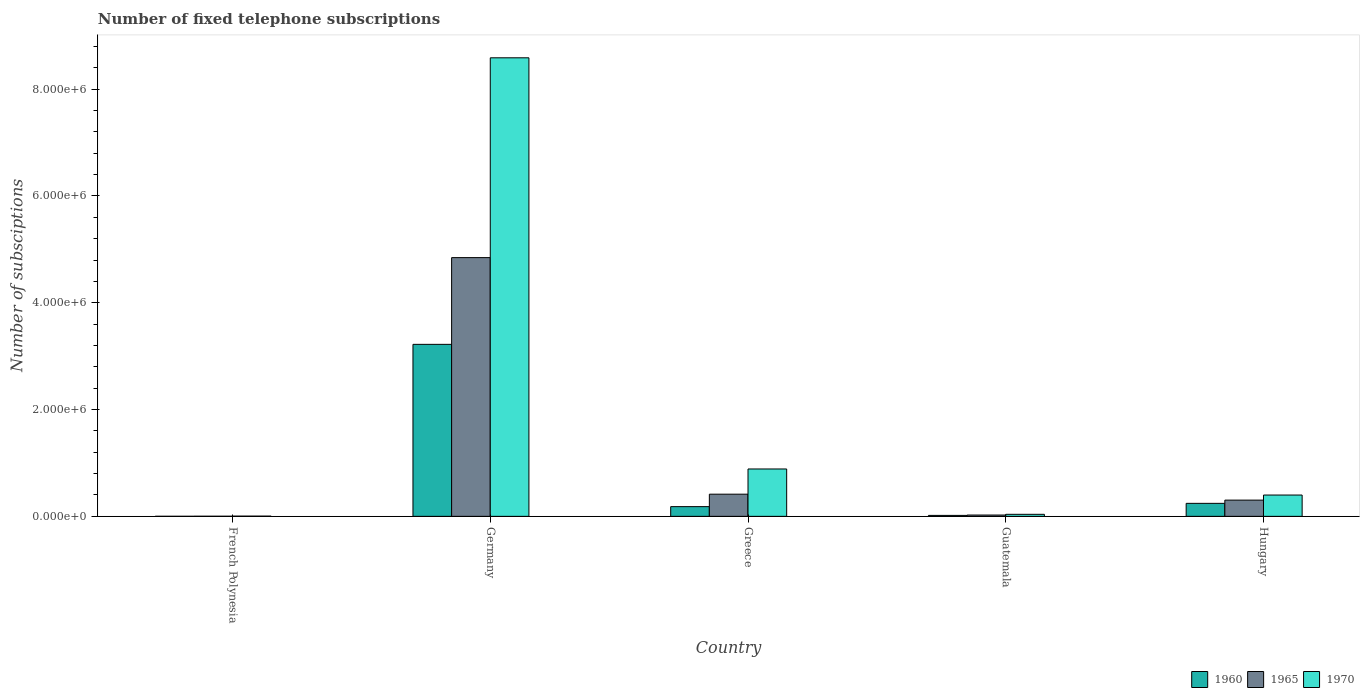How many different coloured bars are there?
Give a very brief answer. 3. How many groups of bars are there?
Offer a very short reply. 5. Are the number of bars per tick equal to the number of legend labels?
Ensure brevity in your answer.  Yes. Are the number of bars on each tick of the X-axis equal?
Your response must be concise. Yes. What is the label of the 5th group of bars from the left?
Your response must be concise. Hungary. What is the number of fixed telephone subscriptions in 1970 in French Polynesia?
Offer a terse response. 4000. Across all countries, what is the maximum number of fixed telephone subscriptions in 1960?
Provide a short and direct response. 3.22e+06. Across all countries, what is the minimum number of fixed telephone subscriptions in 1965?
Ensure brevity in your answer.  1900. In which country was the number of fixed telephone subscriptions in 1970 minimum?
Your answer should be compact. French Polynesia. What is the total number of fixed telephone subscriptions in 1965 in the graph?
Offer a very short reply. 5.59e+06. What is the difference between the number of fixed telephone subscriptions in 1970 in French Polynesia and that in Germany?
Give a very brief answer. -8.58e+06. What is the difference between the number of fixed telephone subscriptions in 1960 in Germany and the number of fixed telephone subscriptions in 1965 in Greece?
Your answer should be compact. 2.81e+06. What is the average number of fixed telephone subscriptions in 1965 per country?
Ensure brevity in your answer.  1.12e+06. What is the difference between the number of fixed telephone subscriptions of/in 1960 and number of fixed telephone subscriptions of/in 1965 in Guatemala?
Your answer should be compact. -6485. In how many countries, is the number of fixed telephone subscriptions in 1960 greater than 5200000?
Give a very brief answer. 0. What is the ratio of the number of fixed telephone subscriptions in 1960 in Germany to that in Guatemala?
Offer a very short reply. 180.74. What is the difference between the highest and the second highest number of fixed telephone subscriptions in 1960?
Keep it short and to the point. -2.98e+06. What is the difference between the highest and the lowest number of fixed telephone subscriptions in 1970?
Keep it short and to the point. 8.58e+06. What does the 2nd bar from the left in Germany represents?
Your answer should be compact. 1965. What does the 2nd bar from the right in Greece represents?
Keep it short and to the point. 1965. Is it the case that in every country, the sum of the number of fixed telephone subscriptions in 1965 and number of fixed telephone subscriptions in 1970 is greater than the number of fixed telephone subscriptions in 1960?
Offer a very short reply. Yes. Does the graph contain any zero values?
Your response must be concise. No. What is the title of the graph?
Your response must be concise. Number of fixed telephone subscriptions. What is the label or title of the X-axis?
Your answer should be very brief. Country. What is the label or title of the Y-axis?
Your answer should be very brief. Number of subsciptions. What is the Number of subsciptions in 1960 in French Polynesia?
Give a very brief answer. 827. What is the Number of subsciptions in 1965 in French Polynesia?
Give a very brief answer. 1900. What is the Number of subsciptions of 1970 in French Polynesia?
Keep it short and to the point. 4000. What is the Number of subsciptions of 1960 in Germany?
Give a very brief answer. 3.22e+06. What is the Number of subsciptions of 1965 in Germany?
Keep it short and to the point. 4.84e+06. What is the Number of subsciptions of 1970 in Germany?
Your answer should be compact. 8.59e+06. What is the Number of subsciptions of 1960 in Greece?
Your answer should be compact. 1.82e+05. What is the Number of subsciptions in 1965 in Greece?
Keep it short and to the point. 4.15e+05. What is the Number of subsciptions of 1970 in Greece?
Provide a short and direct response. 8.87e+05. What is the Number of subsciptions of 1960 in Guatemala?
Offer a terse response. 1.78e+04. What is the Number of subsciptions of 1965 in Guatemala?
Provide a succinct answer. 2.43e+04. What is the Number of subsciptions of 1970 in Guatemala?
Provide a short and direct response. 3.79e+04. What is the Number of subsciptions in 1960 in Hungary?
Give a very brief answer. 2.43e+05. What is the Number of subsciptions in 1965 in Hungary?
Make the answer very short. 3.04e+05. What is the Number of subsciptions of 1970 in Hungary?
Give a very brief answer. 3.99e+05. Across all countries, what is the maximum Number of subsciptions in 1960?
Keep it short and to the point. 3.22e+06. Across all countries, what is the maximum Number of subsciptions of 1965?
Your response must be concise. 4.84e+06. Across all countries, what is the maximum Number of subsciptions in 1970?
Provide a short and direct response. 8.59e+06. Across all countries, what is the minimum Number of subsciptions of 1960?
Provide a succinct answer. 827. Across all countries, what is the minimum Number of subsciptions of 1965?
Ensure brevity in your answer.  1900. Across all countries, what is the minimum Number of subsciptions of 1970?
Your answer should be very brief. 4000. What is the total Number of subsciptions in 1960 in the graph?
Keep it short and to the point. 3.66e+06. What is the total Number of subsciptions of 1965 in the graph?
Ensure brevity in your answer.  5.59e+06. What is the total Number of subsciptions of 1970 in the graph?
Ensure brevity in your answer.  9.91e+06. What is the difference between the Number of subsciptions of 1960 in French Polynesia and that in Germany?
Your answer should be compact. -3.22e+06. What is the difference between the Number of subsciptions of 1965 in French Polynesia and that in Germany?
Keep it short and to the point. -4.84e+06. What is the difference between the Number of subsciptions in 1970 in French Polynesia and that in Germany?
Offer a terse response. -8.58e+06. What is the difference between the Number of subsciptions in 1960 in French Polynesia and that in Greece?
Your answer should be compact. -1.81e+05. What is the difference between the Number of subsciptions in 1965 in French Polynesia and that in Greece?
Make the answer very short. -4.13e+05. What is the difference between the Number of subsciptions in 1970 in French Polynesia and that in Greece?
Give a very brief answer. -8.83e+05. What is the difference between the Number of subsciptions in 1960 in French Polynesia and that in Guatemala?
Offer a very short reply. -1.70e+04. What is the difference between the Number of subsciptions of 1965 in French Polynesia and that in Guatemala?
Offer a terse response. -2.24e+04. What is the difference between the Number of subsciptions of 1970 in French Polynesia and that in Guatemala?
Keep it short and to the point. -3.39e+04. What is the difference between the Number of subsciptions in 1960 in French Polynesia and that in Hungary?
Keep it short and to the point. -2.43e+05. What is the difference between the Number of subsciptions of 1965 in French Polynesia and that in Hungary?
Offer a very short reply. -3.02e+05. What is the difference between the Number of subsciptions of 1970 in French Polynesia and that in Hungary?
Your answer should be compact. -3.95e+05. What is the difference between the Number of subsciptions in 1960 in Germany and that in Greece?
Offer a terse response. 3.04e+06. What is the difference between the Number of subsciptions in 1965 in Germany and that in Greece?
Your response must be concise. 4.43e+06. What is the difference between the Number of subsciptions in 1970 in Germany and that in Greece?
Ensure brevity in your answer.  7.70e+06. What is the difference between the Number of subsciptions of 1960 in Germany and that in Guatemala?
Keep it short and to the point. 3.20e+06. What is the difference between the Number of subsciptions of 1965 in Germany and that in Guatemala?
Give a very brief answer. 4.82e+06. What is the difference between the Number of subsciptions of 1970 in Germany and that in Guatemala?
Your answer should be compact. 8.55e+06. What is the difference between the Number of subsciptions in 1960 in Germany and that in Hungary?
Keep it short and to the point. 2.98e+06. What is the difference between the Number of subsciptions of 1965 in Germany and that in Hungary?
Provide a succinct answer. 4.54e+06. What is the difference between the Number of subsciptions in 1970 in Germany and that in Hungary?
Offer a very short reply. 8.19e+06. What is the difference between the Number of subsciptions of 1960 in Greece and that in Guatemala?
Provide a short and direct response. 1.64e+05. What is the difference between the Number of subsciptions in 1965 in Greece and that in Guatemala?
Your response must be concise. 3.91e+05. What is the difference between the Number of subsciptions of 1970 in Greece and that in Guatemala?
Give a very brief answer. 8.49e+05. What is the difference between the Number of subsciptions in 1960 in Greece and that in Hungary?
Offer a very short reply. -6.17e+04. What is the difference between the Number of subsciptions of 1965 in Greece and that in Hungary?
Ensure brevity in your answer.  1.11e+05. What is the difference between the Number of subsciptions in 1970 in Greece and that in Hungary?
Make the answer very short. 4.88e+05. What is the difference between the Number of subsciptions of 1960 in Guatemala and that in Hungary?
Keep it short and to the point. -2.26e+05. What is the difference between the Number of subsciptions in 1965 in Guatemala and that in Hungary?
Offer a very short reply. -2.79e+05. What is the difference between the Number of subsciptions in 1970 in Guatemala and that in Hungary?
Offer a terse response. -3.61e+05. What is the difference between the Number of subsciptions in 1960 in French Polynesia and the Number of subsciptions in 1965 in Germany?
Your answer should be very brief. -4.84e+06. What is the difference between the Number of subsciptions of 1960 in French Polynesia and the Number of subsciptions of 1970 in Germany?
Offer a very short reply. -8.59e+06. What is the difference between the Number of subsciptions in 1965 in French Polynesia and the Number of subsciptions in 1970 in Germany?
Provide a short and direct response. -8.59e+06. What is the difference between the Number of subsciptions in 1960 in French Polynesia and the Number of subsciptions in 1965 in Greece?
Make the answer very short. -4.14e+05. What is the difference between the Number of subsciptions in 1960 in French Polynesia and the Number of subsciptions in 1970 in Greece?
Give a very brief answer. -8.86e+05. What is the difference between the Number of subsciptions in 1965 in French Polynesia and the Number of subsciptions in 1970 in Greece?
Provide a short and direct response. -8.85e+05. What is the difference between the Number of subsciptions of 1960 in French Polynesia and the Number of subsciptions of 1965 in Guatemala?
Provide a succinct answer. -2.35e+04. What is the difference between the Number of subsciptions in 1960 in French Polynesia and the Number of subsciptions in 1970 in Guatemala?
Make the answer very short. -3.70e+04. What is the difference between the Number of subsciptions in 1965 in French Polynesia and the Number of subsciptions in 1970 in Guatemala?
Keep it short and to the point. -3.60e+04. What is the difference between the Number of subsciptions in 1960 in French Polynesia and the Number of subsciptions in 1965 in Hungary?
Give a very brief answer. -3.03e+05. What is the difference between the Number of subsciptions of 1960 in French Polynesia and the Number of subsciptions of 1970 in Hungary?
Keep it short and to the point. -3.98e+05. What is the difference between the Number of subsciptions in 1965 in French Polynesia and the Number of subsciptions in 1970 in Hungary?
Provide a short and direct response. -3.97e+05. What is the difference between the Number of subsciptions in 1960 in Germany and the Number of subsciptions in 1965 in Greece?
Your answer should be very brief. 2.81e+06. What is the difference between the Number of subsciptions in 1960 in Germany and the Number of subsciptions in 1970 in Greece?
Your answer should be very brief. 2.33e+06. What is the difference between the Number of subsciptions in 1965 in Germany and the Number of subsciptions in 1970 in Greece?
Ensure brevity in your answer.  3.96e+06. What is the difference between the Number of subsciptions in 1960 in Germany and the Number of subsciptions in 1965 in Guatemala?
Provide a succinct answer. 3.20e+06. What is the difference between the Number of subsciptions in 1960 in Germany and the Number of subsciptions in 1970 in Guatemala?
Offer a very short reply. 3.18e+06. What is the difference between the Number of subsciptions of 1965 in Germany and the Number of subsciptions of 1970 in Guatemala?
Ensure brevity in your answer.  4.81e+06. What is the difference between the Number of subsciptions of 1960 in Germany and the Number of subsciptions of 1965 in Hungary?
Provide a succinct answer. 2.92e+06. What is the difference between the Number of subsciptions in 1960 in Germany and the Number of subsciptions in 1970 in Hungary?
Ensure brevity in your answer.  2.82e+06. What is the difference between the Number of subsciptions in 1965 in Germany and the Number of subsciptions in 1970 in Hungary?
Your answer should be compact. 4.45e+06. What is the difference between the Number of subsciptions in 1960 in Greece and the Number of subsciptions in 1965 in Guatemala?
Give a very brief answer. 1.57e+05. What is the difference between the Number of subsciptions of 1960 in Greece and the Number of subsciptions of 1970 in Guatemala?
Provide a short and direct response. 1.44e+05. What is the difference between the Number of subsciptions of 1965 in Greece and the Number of subsciptions of 1970 in Guatemala?
Ensure brevity in your answer.  3.77e+05. What is the difference between the Number of subsciptions in 1960 in Greece and the Number of subsciptions in 1965 in Hungary?
Your response must be concise. -1.22e+05. What is the difference between the Number of subsciptions in 1960 in Greece and the Number of subsciptions in 1970 in Hungary?
Keep it short and to the point. -2.17e+05. What is the difference between the Number of subsciptions of 1965 in Greece and the Number of subsciptions of 1970 in Hungary?
Provide a succinct answer. 1.59e+04. What is the difference between the Number of subsciptions of 1960 in Guatemala and the Number of subsciptions of 1965 in Hungary?
Provide a short and direct response. -2.86e+05. What is the difference between the Number of subsciptions in 1960 in Guatemala and the Number of subsciptions in 1970 in Hungary?
Offer a very short reply. -3.81e+05. What is the difference between the Number of subsciptions in 1965 in Guatemala and the Number of subsciptions in 1970 in Hungary?
Keep it short and to the point. -3.75e+05. What is the average Number of subsciptions in 1960 per country?
Your answer should be very brief. 7.33e+05. What is the average Number of subsciptions in 1965 per country?
Provide a succinct answer. 1.12e+06. What is the average Number of subsciptions of 1970 per country?
Provide a succinct answer. 1.98e+06. What is the difference between the Number of subsciptions in 1960 and Number of subsciptions in 1965 in French Polynesia?
Offer a very short reply. -1073. What is the difference between the Number of subsciptions of 1960 and Number of subsciptions of 1970 in French Polynesia?
Make the answer very short. -3173. What is the difference between the Number of subsciptions in 1965 and Number of subsciptions in 1970 in French Polynesia?
Keep it short and to the point. -2100. What is the difference between the Number of subsciptions in 1960 and Number of subsciptions in 1965 in Germany?
Offer a terse response. -1.62e+06. What is the difference between the Number of subsciptions in 1960 and Number of subsciptions in 1970 in Germany?
Offer a terse response. -5.37e+06. What is the difference between the Number of subsciptions in 1965 and Number of subsciptions in 1970 in Germany?
Your answer should be very brief. -3.74e+06. What is the difference between the Number of subsciptions of 1960 and Number of subsciptions of 1965 in Greece?
Offer a very short reply. -2.33e+05. What is the difference between the Number of subsciptions of 1960 and Number of subsciptions of 1970 in Greece?
Your answer should be compact. -7.05e+05. What is the difference between the Number of subsciptions of 1965 and Number of subsciptions of 1970 in Greece?
Your answer should be compact. -4.72e+05. What is the difference between the Number of subsciptions of 1960 and Number of subsciptions of 1965 in Guatemala?
Your answer should be very brief. -6485. What is the difference between the Number of subsciptions of 1960 and Number of subsciptions of 1970 in Guatemala?
Keep it short and to the point. -2.00e+04. What is the difference between the Number of subsciptions in 1965 and Number of subsciptions in 1970 in Guatemala?
Offer a terse response. -1.36e+04. What is the difference between the Number of subsciptions of 1960 and Number of subsciptions of 1965 in Hungary?
Your answer should be very brief. -6.04e+04. What is the difference between the Number of subsciptions of 1960 and Number of subsciptions of 1970 in Hungary?
Provide a succinct answer. -1.56e+05. What is the difference between the Number of subsciptions of 1965 and Number of subsciptions of 1970 in Hungary?
Offer a terse response. -9.53e+04. What is the ratio of the Number of subsciptions in 1960 in French Polynesia to that in Germany?
Offer a very short reply. 0. What is the ratio of the Number of subsciptions of 1970 in French Polynesia to that in Germany?
Your answer should be very brief. 0. What is the ratio of the Number of subsciptions of 1960 in French Polynesia to that in Greece?
Your response must be concise. 0. What is the ratio of the Number of subsciptions in 1965 in French Polynesia to that in Greece?
Ensure brevity in your answer.  0. What is the ratio of the Number of subsciptions in 1970 in French Polynesia to that in Greece?
Your response must be concise. 0. What is the ratio of the Number of subsciptions in 1960 in French Polynesia to that in Guatemala?
Your answer should be very brief. 0.05. What is the ratio of the Number of subsciptions of 1965 in French Polynesia to that in Guatemala?
Keep it short and to the point. 0.08. What is the ratio of the Number of subsciptions of 1970 in French Polynesia to that in Guatemala?
Make the answer very short. 0.11. What is the ratio of the Number of subsciptions in 1960 in French Polynesia to that in Hungary?
Offer a very short reply. 0. What is the ratio of the Number of subsciptions in 1965 in French Polynesia to that in Hungary?
Your answer should be very brief. 0.01. What is the ratio of the Number of subsciptions of 1970 in French Polynesia to that in Hungary?
Make the answer very short. 0.01. What is the ratio of the Number of subsciptions in 1960 in Germany to that in Greece?
Give a very brief answer. 17.72. What is the ratio of the Number of subsciptions in 1965 in Germany to that in Greece?
Your response must be concise. 11.67. What is the ratio of the Number of subsciptions of 1970 in Germany to that in Greece?
Your response must be concise. 9.68. What is the ratio of the Number of subsciptions of 1960 in Germany to that in Guatemala?
Offer a terse response. 180.74. What is the ratio of the Number of subsciptions in 1965 in Germany to that in Guatemala?
Keep it short and to the point. 199.33. What is the ratio of the Number of subsciptions in 1970 in Germany to that in Guatemala?
Keep it short and to the point. 226.74. What is the ratio of the Number of subsciptions of 1960 in Germany to that in Hungary?
Your answer should be very brief. 13.23. What is the ratio of the Number of subsciptions of 1965 in Germany to that in Hungary?
Ensure brevity in your answer.  15.95. What is the ratio of the Number of subsciptions of 1970 in Germany to that in Hungary?
Your answer should be compact. 21.52. What is the ratio of the Number of subsciptions in 1960 in Greece to that in Guatemala?
Offer a very short reply. 10.2. What is the ratio of the Number of subsciptions in 1965 in Greece to that in Guatemala?
Provide a short and direct response. 17.07. What is the ratio of the Number of subsciptions of 1970 in Greece to that in Guatemala?
Make the answer very short. 23.42. What is the ratio of the Number of subsciptions in 1960 in Greece to that in Hungary?
Make the answer very short. 0.75. What is the ratio of the Number of subsciptions of 1965 in Greece to that in Hungary?
Offer a very short reply. 1.37. What is the ratio of the Number of subsciptions of 1970 in Greece to that in Hungary?
Offer a terse response. 2.22. What is the ratio of the Number of subsciptions of 1960 in Guatemala to that in Hungary?
Ensure brevity in your answer.  0.07. What is the ratio of the Number of subsciptions in 1970 in Guatemala to that in Hungary?
Provide a short and direct response. 0.09. What is the difference between the highest and the second highest Number of subsciptions in 1960?
Give a very brief answer. 2.98e+06. What is the difference between the highest and the second highest Number of subsciptions of 1965?
Keep it short and to the point. 4.43e+06. What is the difference between the highest and the second highest Number of subsciptions of 1970?
Your answer should be compact. 7.70e+06. What is the difference between the highest and the lowest Number of subsciptions in 1960?
Offer a very short reply. 3.22e+06. What is the difference between the highest and the lowest Number of subsciptions of 1965?
Give a very brief answer. 4.84e+06. What is the difference between the highest and the lowest Number of subsciptions in 1970?
Provide a short and direct response. 8.58e+06. 